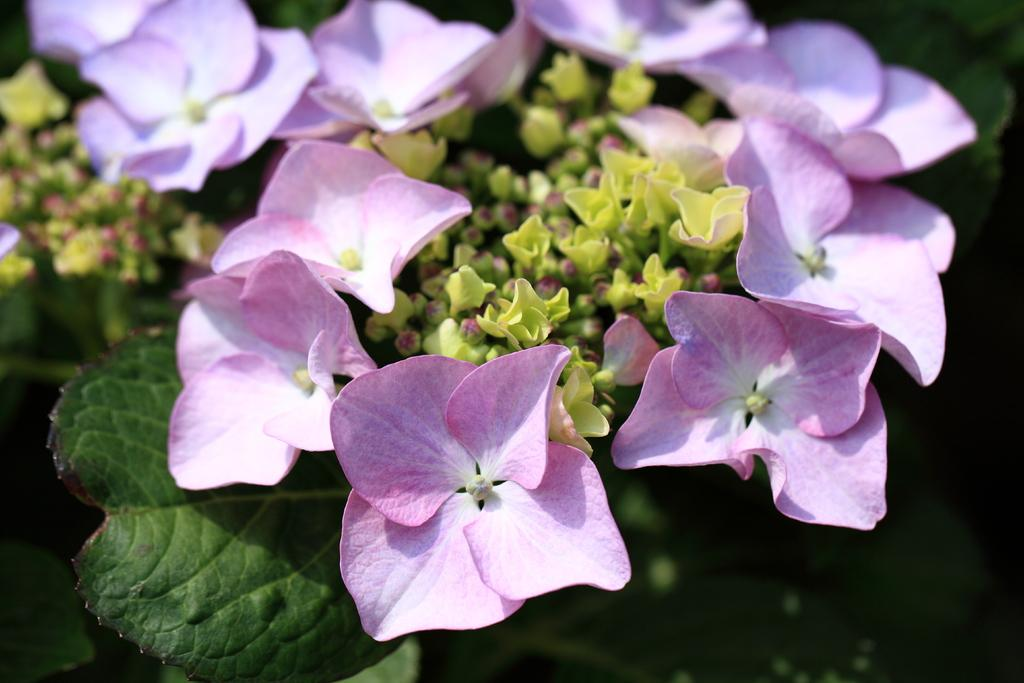What is present in the image? There is a plant in the image. What can be observed about the plant? The plant has flowers. What colors are the flowers? The flowers are in light pink and light violet colors. Are there any unopened flowers on the plant? Yes, there are buds on the plant. How many boys are playing with the deer in the image? There are no boys or deer present in the image; it features a plant with flowers and buds. 